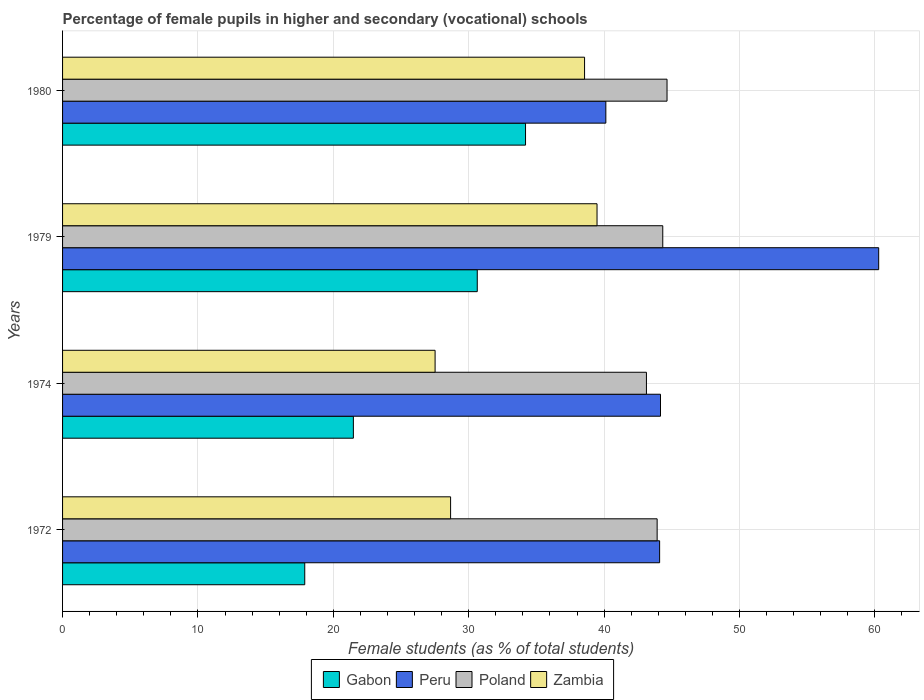How many groups of bars are there?
Keep it short and to the point. 4. What is the label of the 1st group of bars from the top?
Your answer should be very brief. 1980. What is the percentage of female pupils in higher and secondary schools in Gabon in 1974?
Give a very brief answer. 21.48. Across all years, what is the maximum percentage of female pupils in higher and secondary schools in Zambia?
Keep it short and to the point. 39.48. Across all years, what is the minimum percentage of female pupils in higher and secondary schools in Poland?
Give a very brief answer. 43.13. In which year was the percentage of female pupils in higher and secondary schools in Peru maximum?
Your answer should be compact. 1979. In which year was the percentage of female pupils in higher and secondary schools in Peru minimum?
Make the answer very short. 1980. What is the total percentage of female pupils in higher and secondary schools in Poland in the graph?
Offer a terse response. 176.02. What is the difference between the percentage of female pupils in higher and secondary schools in Peru in 1974 and that in 1979?
Offer a terse response. -16.12. What is the difference between the percentage of female pupils in higher and secondary schools in Gabon in 1979 and the percentage of female pupils in higher and secondary schools in Peru in 1972?
Your answer should be compact. -13.47. What is the average percentage of female pupils in higher and secondary schools in Peru per year?
Give a very brief answer. 47.17. In the year 1979, what is the difference between the percentage of female pupils in higher and secondary schools in Gabon and percentage of female pupils in higher and secondary schools in Zambia?
Offer a very short reply. -8.85. What is the ratio of the percentage of female pupils in higher and secondary schools in Zambia in 1972 to that in 1980?
Offer a very short reply. 0.74. What is the difference between the highest and the second highest percentage of female pupils in higher and secondary schools in Zambia?
Your response must be concise. 0.92. What is the difference between the highest and the lowest percentage of female pupils in higher and secondary schools in Poland?
Offer a terse response. 1.52. In how many years, is the percentage of female pupils in higher and secondary schools in Gabon greater than the average percentage of female pupils in higher and secondary schools in Gabon taken over all years?
Offer a terse response. 2. What does the 1st bar from the top in 1979 represents?
Make the answer very short. Zambia. Is it the case that in every year, the sum of the percentage of female pupils in higher and secondary schools in Poland and percentage of female pupils in higher and secondary schools in Zambia is greater than the percentage of female pupils in higher and secondary schools in Peru?
Offer a terse response. Yes. Does the graph contain any zero values?
Give a very brief answer. No. Does the graph contain grids?
Provide a short and direct response. Yes. How are the legend labels stacked?
Make the answer very short. Horizontal. What is the title of the graph?
Keep it short and to the point. Percentage of female pupils in higher and secondary (vocational) schools. What is the label or title of the X-axis?
Give a very brief answer. Female students (as % of total students). What is the Female students (as % of total students) in Gabon in 1972?
Offer a terse response. 17.89. What is the Female students (as % of total students) of Peru in 1972?
Provide a short and direct response. 44.1. What is the Female students (as % of total students) of Poland in 1972?
Keep it short and to the point. 43.92. What is the Female students (as % of total students) of Zambia in 1972?
Your answer should be compact. 28.66. What is the Female students (as % of total students) in Gabon in 1974?
Your answer should be compact. 21.48. What is the Female students (as % of total students) of Peru in 1974?
Your answer should be compact. 44.17. What is the Female students (as % of total students) of Poland in 1974?
Provide a succinct answer. 43.13. What is the Female students (as % of total students) in Zambia in 1974?
Make the answer very short. 27.52. What is the Female students (as % of total students) in Gabon in 1979?
Make the answer very short. 30.63. What is the Female students (as % of total students) of Peru in 1979?
Offer a very short reply. 60.28. What is the Female students (as % of total students) of Poland in 1979?
Your answer should be compact. 44.33. What is the Female students (as % of total students) in Zambia in 1979?
Offer a very short reply. 39.48. What is the Female students (as % of total students) in Gabon in 1980?
Provide a short and direct response. 34.2. What is the Female students (as % of total students) of Peru in 1980?
Your response must be concise. 40.13. What is the Female students (as % of total students) in Poland in 1980?
Offer a very short reply. 44.65. What is the Female students (as % of total students) of Zambia in 1980?
Ensure brevity in your answer.  38.56. Across all years, what is the maximum Female students (as % of total students) in Gabon?
Your answer should be compact. 34.2. Across all years, what is the maximum Female students (as % of total students) in Peru?
Provide a succinct answer. 60.28. Across all years, what is the maximum Female students (as % of total students) of Poland?
Offer a terse response. 44.65. Across all years, what is the maximum Female students (as % of total students) in Zambia?
Your answer should be very brief. 39.48. Across all years, what is the minimum Female students (as % of total students) of Gabon?
Your response must be concise. 17.89. Across all years, what is the minimum Female students (as % of total students) in Peru?
Your answer should be very brief. 40.13. Across all years, what is the minimum Female students (as % of total students) in Poland?
Offer a very short reply. 43.13. Across all years, what is the minimum Female students (as % of total students) in Zambia?
Offer a terse response. 27.52. What is the total Female students (as % of total students) of Gabon in the graph?
Provide a short and direct response. 104.19. What is the total Female students (as % of total students) in Peru in the graph?
Your response must be concise. 188.67. What is the total Female students (as % of total students) in Poland in the graph?
Provide a succinct answer. 176.02. What is the total Female students (as % of total students) in Zambia in the graph?
Offer a terse response. 134.21. What is the difference between the Female students (as % of total students) in Gabon in 1972 and that in 1974?
Make the answer very short. -3.59. What is the difference between the Female students (as % of total students) in Peru in 1972 and that in 1974?
Your answer should be very brief. -0.07. What is the difference between the Female students (as % of total students) of Poland in 1972 and that in 1974?
Provide a short and direct response. 0.79. What is the difference between the Female students (as % of total students) of Zambia in 1972 and that in 1974?
Provide a short and direct response. 1.14. What is the difference between the Female students (as % of total students) in Gabon in 1972 and that in 1979?
Your answer should be compact. -12.74. What is the difference between the Female students (as % of total students) of Peru in 1972 and that in 1979?
Ensure brevity in your answer.  -16.18. What is the difference between the Female students (as % of total students) in Poland in 1972 and that in 1979?
Your response must be concise. -0.41. What is the difference between the Female students (as % of total students) in Zambia in 1972 and that in 1979?
Provide a succinct answer. -10.82. What is the difference between the Female students (as % of total students) in Gabon in 1972 and that in 1980?
Offer a very short reply. -16.31. What is the difference between the Female students (as % of total students) of Peru in 1972 and that in 1980?
Provide a short and direct response. 3.97. What is the difference between the Female students (as % of total students) in Poland in 1972 and that in 1980?
Your answer should be very brief. -0.73. What is the difference between the Female students (as % of total students) of Zambia in 1972 and that in 1980?
Provide a succinct answer. -9.9. What is the difference between the Female students (as % of total students) of Gabon in 1974 and that in 1979?
Provide a succinct answer. -9.15. What is the difference between the Female students (as % of total students) of Peru in 1974 and that in 1979?
Offer a terse response. -16.12. What is the difference between the Female students (as % of total students) of Poland in 1974 and that in 1979?
Keep it short and to the point. -1.21. What is the difference between the Female students (as % of total students) in Zambia in 1974 and that in 1979?
Keep it short and to the point. -11.96. What is the difference between the Female students (as % of total students) of Gabon in 1974 and that in 1980?
Your answer should be very brief. -12.72. What is the difference between the Female students (as % of total students) of Peru in 1974 and that in 1980?
Give a very brief answer. 4.04. What is the difference between the Female students (as % of total students) in Poland in 1974 and that in 1980?
Your response must be concise. -1.52. What is the difference between the Female students (as % of total students) in Zambia in 1974 and that in 1980?
Your response must be concise. -11.04. What is the difference between the Female students (as % of total students) of Gabon in 1979 and that in 1980?
Your answer should be very brief. -3.57. What is the difference between the Female students (as % of total students) of Peru in 1979 and that in 1980?
Provide a succinct answer. 20.15. What is the difference between the Female students (as % of total students) in Poland in 1979 and that in 1980?
Offer a very short reply. -0.32. What is the difference between the Female students (as % of total students) of Zambia in 1979 and that in 1980?
Offer a very short reply. 0.92. What is the difference between the Female students (as % of total students) in Gabon in 1972 and the Female students (as % of total students) in Peru in 1974?
Provide a succinct answer. -26.28. What is the difference between the Female students (as % of total students) in Gabon in 1972 and the Female students (as % of total students) in Poland in 1974?
Your answer should be very brief. -25.24. What is the difference between the Female students (as % of total students) of Gabon in 1972 and the Female students (as % of total students) of Zambia in 1974?
Make the answer very short. -9.63. What is the difference between the Female students (as % of total students) of Peru in 1972 and the Female students (as % of total students) of Zambia in 1974?
Provide a short and direct response. 16.58. What is the difference between the Female students (as % of total students) of Poland in 1972 and the Female students (as % of total students) of Zambia in 1974?
Provide a short and direct response. 16.4. What is the difference between the Female students (as % of total students) in Gabon in 1972 and the Female students (as % of total students) in Peru in 1979?
Your answer should be very brief. -42.39. What is the difference between the Female students (as % of total students) of Gabon in 1972 and the Female students (as % of total students) of Poland in 1979?
Your answer should be compact. -26.44. What is the difference between the Female students (as % of total students) in Gabon in 1972 and the Female students (as % of total students) in Zambia in 1979?
Your answer should be compact. -21.59. What is the difference between the Female students (as % of total students) in Peru in 1972 and the Female students (as % of total students) in Poland in 1979?
Provide a short and direct response. -0.23. What is the difference between the Female students (as % of total students) of Peru in 1972 and the Female students (as % of total students) of Zambia in 1979?
Make the answer very short. 4.62. What is the difference between the Female students (as % of total students) in Poland in 1972 and the Female students (as % of total students) in Zambia in 1979?
Keep it short and to the point. 4.44. What is the difference between the Female students (as % of total students) of Gabon in 1972 and the Female students (as % of total students) of Peru in 1980?
Give a very brief answer. -22.24. What is the difference between the Female students (as % of total students) of Gabon in 1972 and the Female students (as % of total students) of Poland in 1980?
Provide a short and direct response. -26.76. What is the difference between the Female students (as % of total students) in Gabon in 1972 and the Female students (as % of total students) in Zambia in 1980?
Provide a short and direct response. -20.67. What is the difference between the Female students (as % of total students) of Peru in 1972 and the Female students (as % of total students) of Poland in 1980?
Your answer should be compact. -0.55. What is the difference between the Female students (as % of total students) in Peru in 1972 and the Female students (as % of total students) in Zambia in 1980?
Provide a succinct answer. 5.54. What is the difference between the Female students (as % of total students) in Poland in 1972 and the Female students (as % of total students) in Zambia in 1980?
Keep it short and to the point. 5.36. What is the difference between the Female students (as % of total students) of Gabon in 1974 and the Female students (as % of total students) of Peru in 1979?
Your answer should be very brief. -38.8. What is the difference between the Female students (as % of total students) of Gabon in 1974 and the Female students (as % of total students) of Poland in 1979?
Keep it short and to the point. -22.85. What is the difference between the Female students (as % of total students) of Gabon in 1974 and the Female students (as % of total students) of Zambia in 1979?
Provide a short and direct response. -18. What is the difference between the Female students (as % of total students) of Peru in 1974 and the Female students (as % of total students) of Poland in 1979?
Give a very brief answer. -0.17. What is the difference between the Female students (as % of total students) in Peru in 1974 and the Female students (as % of total students) in Zambia in 1979?
Provide a succinct answer. 4.69. What is the difference between the Female students (as % of total students) of Poland in 1974 and the Female students (as % of total students) of Zambia in 1979?
Provide a succinct answer. 3.65. What is the difference between the Female students (as % of total students) in Gabon in 1974 and the Female students (as % of total students) in Peru in 1980?
Offer a very short reply. -18.65. What is the difference between the Female students (as % of total students) in Gabon in 1974 and the Female students (as % of total students) in Poland in 1980?
Offer a very short reply. -23.17. What is the difference between the Female students (as % of total students) of Gabon in 1974 and the Female students (as % of total students) of Zambia in 1980?
Give a very brief answer. -17.08. What is the difference between the Female students (as % of total students) of Peru in 1974 and the Female students (as % of total students) of Poland in 1980?
Provide a succinct answer. -0.48. What is the difference between the Female students (as % of total students) of Peru in 1974 and the Female students (as % of total students) of Zambia in 1980?
Your answer should be compact. 5.61. What is the difference between the Female students (as % of total students) in Poland in 1974 and the Female students (as % of total students) in Zambia in 1980?
Offer a very short reply. 4.57. What is the difference between the Female students (as % of total students) in Gabon in 1979 and the Female students (as % of total students) in Peru in 1980?
Give a very brief answer. -9.5. What is the difference between the Female students (as % of total students) of Gabon in 1979 and the Female students (as % of total students) of Poland in 1980?
Offer a very short reply. -14.02. What is the difference between the Female students (as % of total students) in Gabon in 1979 and the Female students (as % of total students) in Zambia in 1980?
Provide a short and direct response. -7.93. What is the difference between the Female students (as % of total students) of Peru in 1979 and the Female students (as % of total students) of Poland in 1980?
Offer a terse response. 15.63. What is the difference between the Female students (as % of total students) in Peru in 1979 and the Female students (as % of total students) in Zambia in 1980?
Offer a very short reply. 21.72. What is the difference between the Female students (as % of total students) of Poland in 1979 and the Female students (as % of total students) of Zambia in 1980?
Your answer should be compact. 5.78. What is the average Female students (as % of total students) of Gabon per year?
Give a very brief answer. 26.05. What is the average Female students (as % of total students) in Peru per year?
Your answer should be very brief. 47.17. What is the average Female students (as % of total students) in Poland per year?
Offer a terse response. 44.01. What is the average Female students (as % of total students) in Zambia per year?
Your answer should be very brief. 33.55. In the year 1972, what is the difference between the Female students (as % of total students) in Gabon and Female students (as % of total students) in Peru?
Offer a very short reply. -26.21. In the year 1972, what is the difference between the Female students (as % of total students) of Gabon and Female students (as % of total students) of Poland?
Your answer should be very brief. -26.03. In the year 1972, what is the difference between the Female students (as % of total students) in Gabon and Female students (as % of total students) in Zambia?
Provide a short and direct response. -10.77. In the year 1972, what is the difference between the Female students (as % of total students) of Peru and Female students (as % of total students) of Poland?
Provide a succinct answer. 0.18. In the year 1972, what is the difference between the Female students (as % of total students) in Peru and Female students (as % of total students) in Zambia?
Your answer should be very brief. 15.44. In the year 1972, what is the difference between the Female students (as % of total students) of Poland and Female students (as % of total students) of Zambia?
Your answer should be compact. 15.26. In the year 1974, what is the difference between the Female students (as % of total students) of Gabon and Female students (as % of total students) of Peru?
Provide a short and direct response. -22.69. In the year 1974, what is the difference between the Female students (as % of total students) in Gabon and Female students (as % of total students) in Poland?
Your answer should be very brief. -21.65. In the year 1974, what is the difference between the Female students (as % of total students) in Gabon and Female students (as % of total students) in Zambia?
Your response must be concise. -6.04. In the year 1974, what is the difference between the Female students (as % of total students) in Peru and Female students (as % of total students) in Poland?
Offer a terse response. 1.04. In the year 1974, what is the difference between the Female students (as % of total students) in Peru and Female students (as % of total students) in Zambia?
Keep it short and to the point. 16.65. In the year 1974, what is the difference between the Female students (as % of total students) in Poland and Female students (as % of total students) in Zambia?
Ensure brevity in your answer.  15.61. In the year 1979, what is the difference between the Female students (as % of total students) of Gabon and Female students (as % of total students) of Peru?
Give a very brief answer. -29.65. In the year 1979, what is the difference between the Female students (as % of total students) in Gabon and Female students (as % of total students) in Poland?
Your answer should be compact. -13.7. In the year 1979, what is the difference between the Female students (as % of total students) of Gabon and Female students (as % of total students) of Zambia?
Provide a short and direct response. -8.85. In the year 1979, what is the difference between the Female students (as % of total students) of Peru and Female students (as % of total students) of Poland?
Offer a very short reply. 15.95. In the year 1979, what is the difference between the Female students (as % of total students) in Peru and Female students (as % of total students) in Zambia?
Make the answer very short. 20.8. In the year 1979, what is the difference between the Female students (as % of total students) in Poland and Female students (as % of total students) in Zambia?
Make the answer very short. 4.86. In the year 1980, what is the difference between the Female students (as % of total students) of Gabon and Female students (as % of total students) of Peru?
Keep it short and to the point. -5.93. In the year 1980, what is the difference between the Female students (as % of total students) of Gabon and Female students (as % of total students) of Poland?
Provide a short and direct response. -10.45. In the year 1980, what is the difference between the Female students (as % of total students) in Gabon and Female students (as % of total students) in Zambia?
Make the answer very short. -4.36. In the year 1980, what is the difference between the Female students (as % of total students) of Peru and Female students (as % of total students) of Poland?
Provide a short and direct response. -4.52. In the year 1980, what is the difference between the Female students (as % of total students) of Peru and Female students (as % of total students) of Zambia?
Keep it short and to the point. 1.57. In the year 1980, what is the difference between the Female students (as % of total students) in Poland and Female students (as % of total students) in Zambia?
Offer a terse response. 6.09. What is the ratio of the Female students (as % of total students) of Gabon in 1972 to that in 1974?
Offer a terse response. 0.83. What is the ratio of the Female students (as % of total students) in Poland in 1972 to that in 1974?
Give a very brief answer. 1.02. What is the ratio of the Female students (as % of total students) of Zambia in 1972 to that in 1974?
Provide a short and direct response. 1.04. What is the ratio of the Female students (as % of total students) in Gabon in 1972 to that in 1979?
Provide a short and direct response. 0.58. What is the ratio of the Female students (as % of total students) in Peru in 1972 to that in 1979?
Give a very brief answer. 0.73. What is the ratio of the Female students (as % of total students) in Poland in 1972 to that in 1979?
Your answer should be very brief. 0.99. What is the ratio of the Female students (as % of total students) in Zambia in 1972 to that in 1979?
Your answer should be very brief. 0.73. What is the ratio of the Female students (as % of total students) in Gabon in 1972 to that in 1980?
Your response must be concise. 0.52. What is the ratio of the Female students (as % of total students) in Peru in 1972 to that in 1980?
Offer a very short reply. 1.1. What is the ratio of the Female students (as % of total students) in Poland in 1972 to that in 1980?
Provide a short and direct response. 0.98. What is the ratio of the Female students (as % of total students) in Zambia in 1972 to that in 1980?
Your answer should be very brief. 0.74. What is the ratio of the Female students (as % of total students) in Gabon in 1974 to that in 1979?
Provide a short and direct response. 0.7. What is the ratio of the Female students (as % of total students) in Peru in 1974 to that in 1979?
Provide a short and direct response. 0.73. What is the ratio of the Female students (as % of total students) in Poland in 1974 to that in 1979?
Your answer should be compact. 0.97. What is the ratio of the Female students (as % of total students) of Zambia in 1974 to that in 1979?
Provide a short and direct response. 0.7. What is the ratio of the Female students (as % of total students) of Gabon in 1974 to that in 1980?
Your answer should be very brief. 0.63. What is the ratio of the Female students (as % of total students) in Peru in 1974 to that in 1980?
Make the answer very short. 1.1. What is the ratio of the Female students (as % of total students) in Poland in 1974 to that in 1980?
Your answer should be very brief. 0.97. What is the ratio of the Female students (as % of total students) in Zambia in 1974 to that in 1980?
Your answer should be very brief. 0.71. What is the ratio of the Female students (as % of total students) of Gabon in 1979 to that in 1980?
Give a very brief answer. 0.9. What is the ratio of the Female students (as % of total students) of Peru in 1979 to that in 1980?
Your answer should be very brief. 1.5. What is the ratio of the Female students (as % of total students) of Poland in 1979 to that in 1980?
Provide a short and direct response. 0.99. What is the ratio of the Female students (as % of total students) of Zambia in 1979 to that in 1980?
Give a very brief answer. 1.02. What is the difference between the highest and the second highest Female students (as % of total students) of Gabon?
Give a very brief answer. 3.57. What is the difference between the highest and the second highest Female students (as % of total students) in Peru?
Offer a very short reply. 16.12. What is the difference between the highest and the second highest Female students (as % of total students) of Poland?
Give a very brief answer. 0.32. What is the difference between the highest and the second highest Female students (as % of total students) of Zambia?
Provide a succinct answer. 0.92. What is the difference between the highest and the lowest Female students (as % of total students) of Gabon?
Make the answer very short. 16.31. What is the difference between the highest and the lowest Female students (as % of total students) in Peru?
Provide a succinct answer. 20.15. What is the difference between the highest and the lowest Female students (as % of total students) of Poland?
Make the answer very short. 1.52. What is the difference between the highest and the lowest Female students (as % of total students) in Zambia?
Make the answer very short. 11.96. 